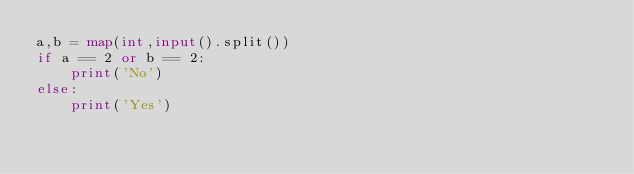Convert code to text. <code><loc_0><loc_0><loc_500><loc_500><_Python_>a,b = map(int,input().split())
if a == 2 or b == 2:
    print('No')
else:
    print('Yes')</code> 